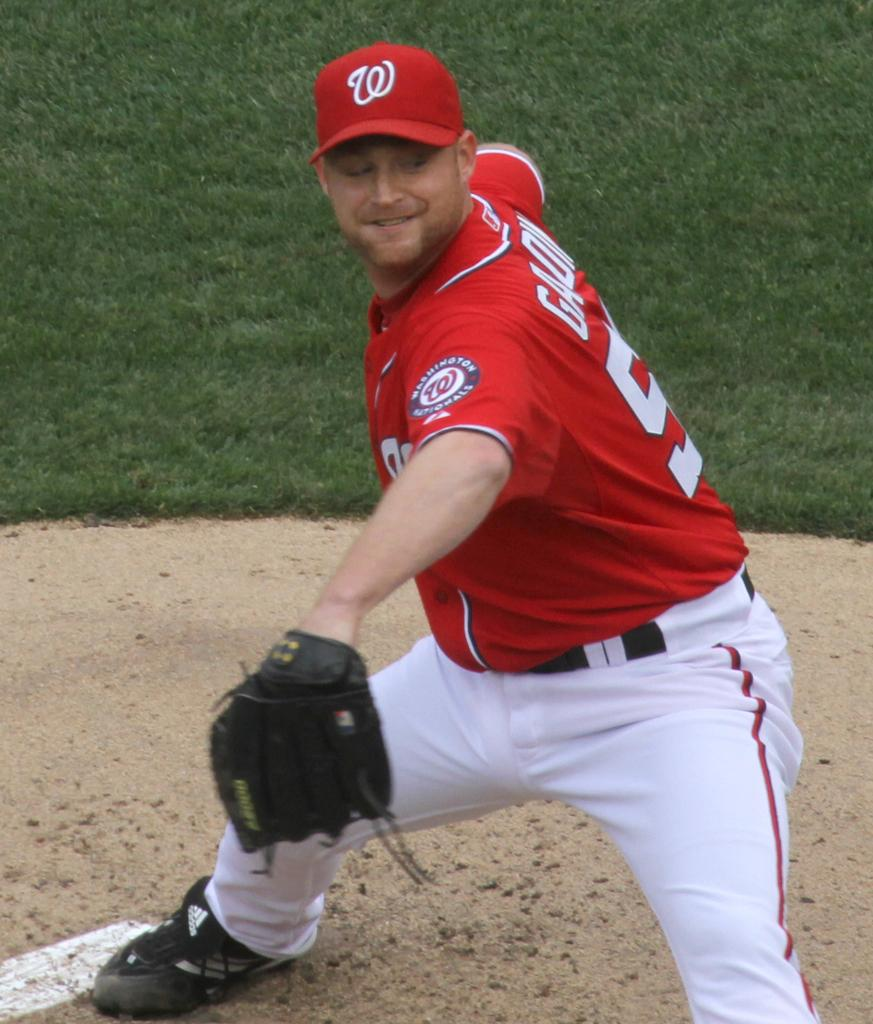<image>
Create a compact narrative representing the image presented. A pitcher for the Washington National throws a pitch during a baseball game. 